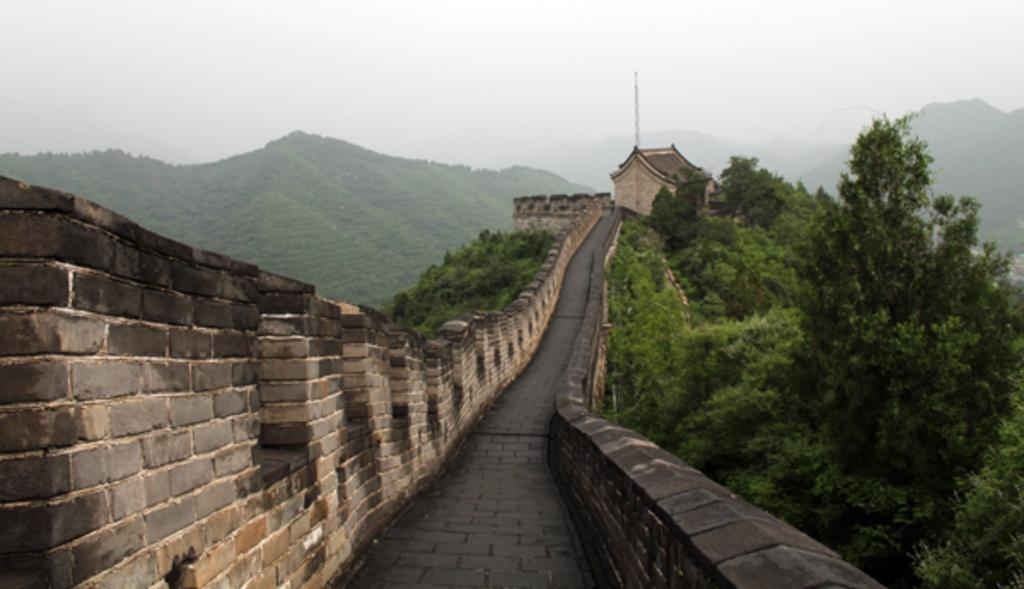What is the main feature of the image? There is a path in the image. What surrounds the path? There are walls on either side of the path. What can be seen in the background of the image? There are trees on the hills in the background of the image. What atmospheric condition is present in the image? Fog is visible in the image. What is the love rate of the trees in the image? There is no concept of love rate applicable to trees in the image. Trees are inanimate objects and do not experience emotions like love. 